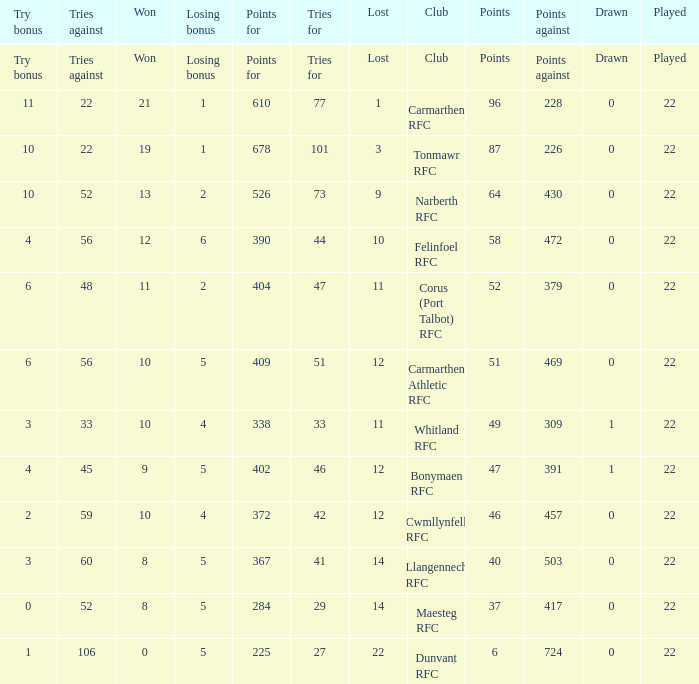Name the tries against for drawn 1.0. 